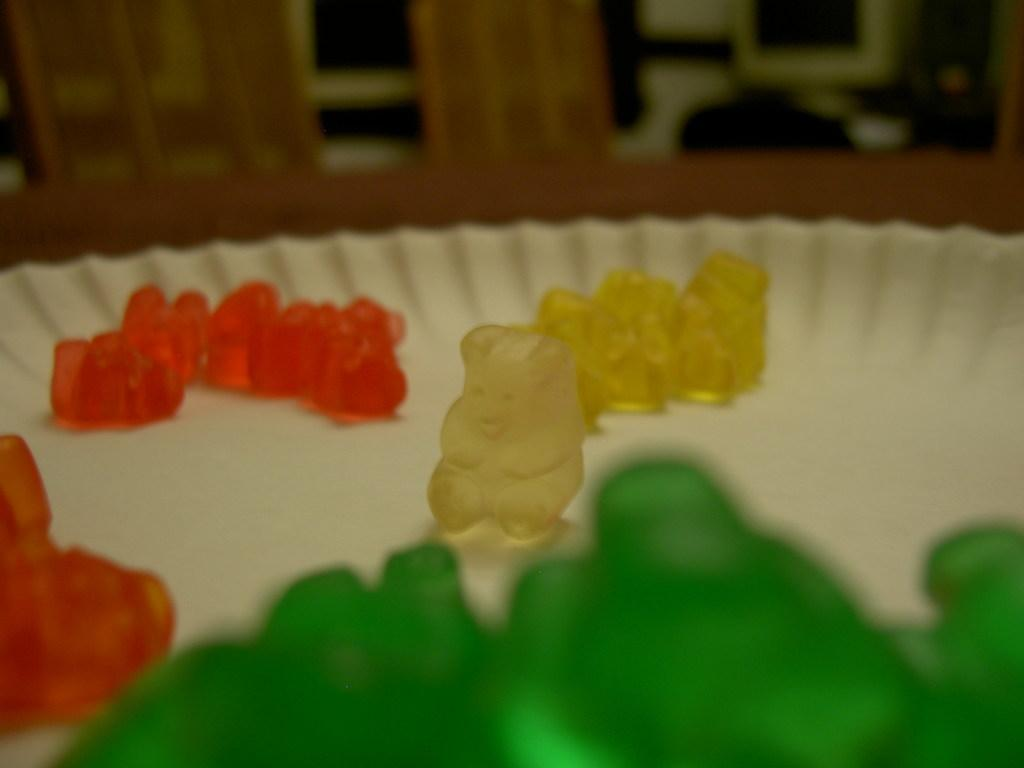What type of food items are present in the image? There are candies in the image. How do the candies differ from each other? The candies are in different shapes and colors. What is the color of the plate on which the candies are placed? The candies are placed on a white color plate. What type of government is depicted in the image? There is no depiction of a government in the image; it features candies in different shapes and colors on a white plate. 